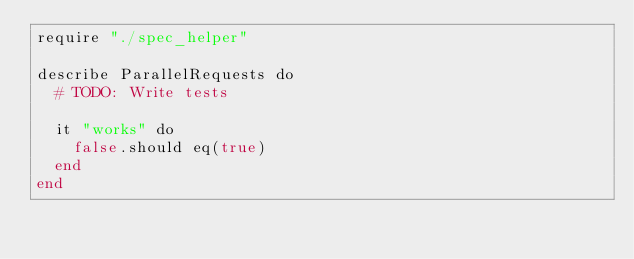Convert code to text. <code><loc_0><loc_0><loc_500><loc_500><_Crystal_>require "./spec_helper"

describe ParallelRequests do
  # TODO: Write tests

  it "works" do
    false.should eq(true)
  end
end
</code> 